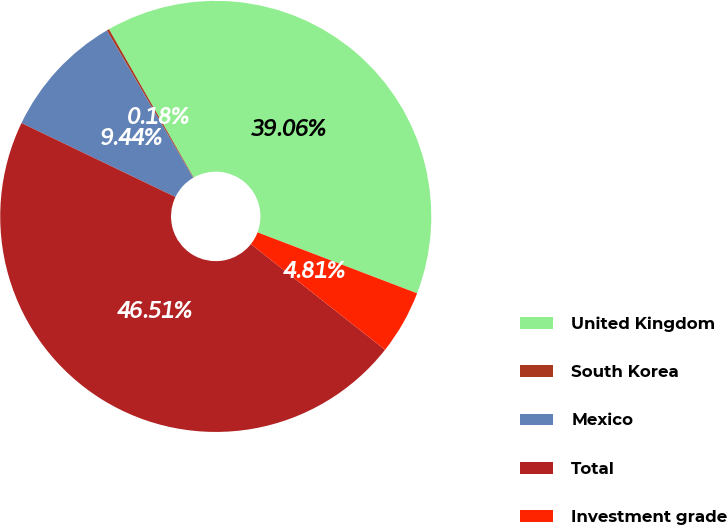<chart> <loc_0><loc_0><loc_500><loc_500><pie_chart><fcel>United Kingdom<fcel>South Korea<fcel>Mexico<fcel>Total<fcel>Investment grade<nl><fcel>39.06%<fcel>0.18%<fcel>9.44%<fcel>46.51%<fcel>4.81%<nl></chart> 